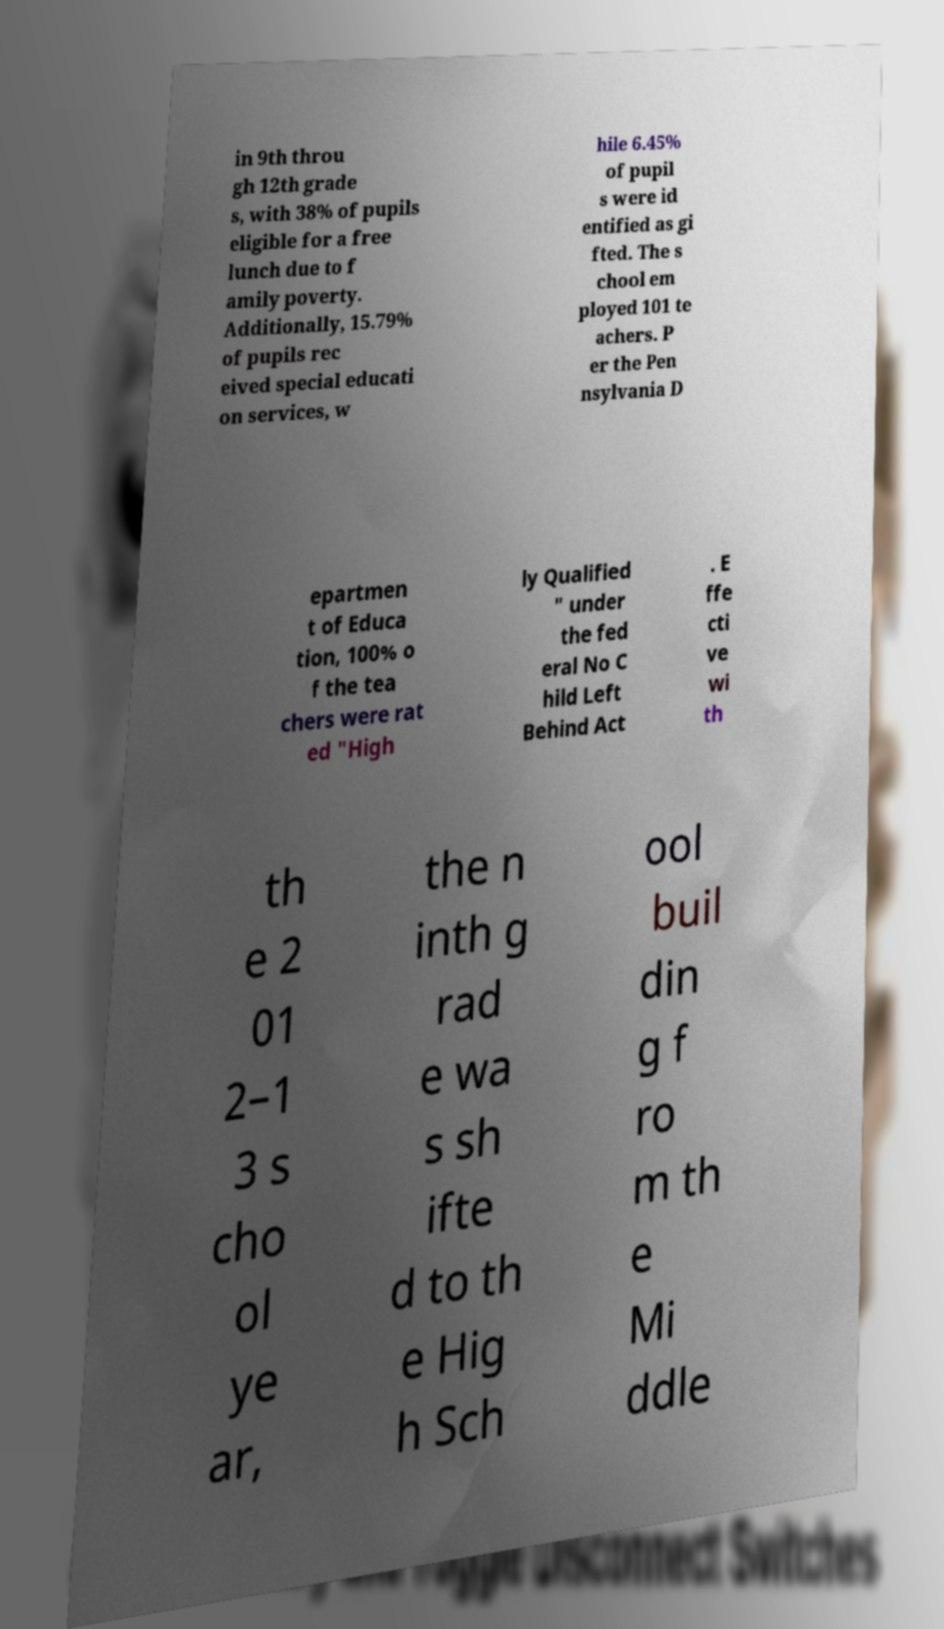Please identify and transcribe the text found in this image. in 9th throu gh 12th grade s, with 38% of pupils eligible for a free lunch due to f amily poverty. Additionally, 15.79% of pupils rec eived special educati on services, w hile 6.45% of pupil s were id entified as gi fted. The s chool em ployed 101 te achers. P er the Pen nsylvania D epartmen t of Educa tion, 100% o f the tea chers were rat ed "High ly Qualified " under the fed eral No C hild Left Behind Act . E ffe cti ve wi th th e 2 01 2–1 3 s cho ol ye ar, the n inth g rad e wa s sh ifte d to th e Hig h Sch ool buil din g f ro m th e Mi ddle 